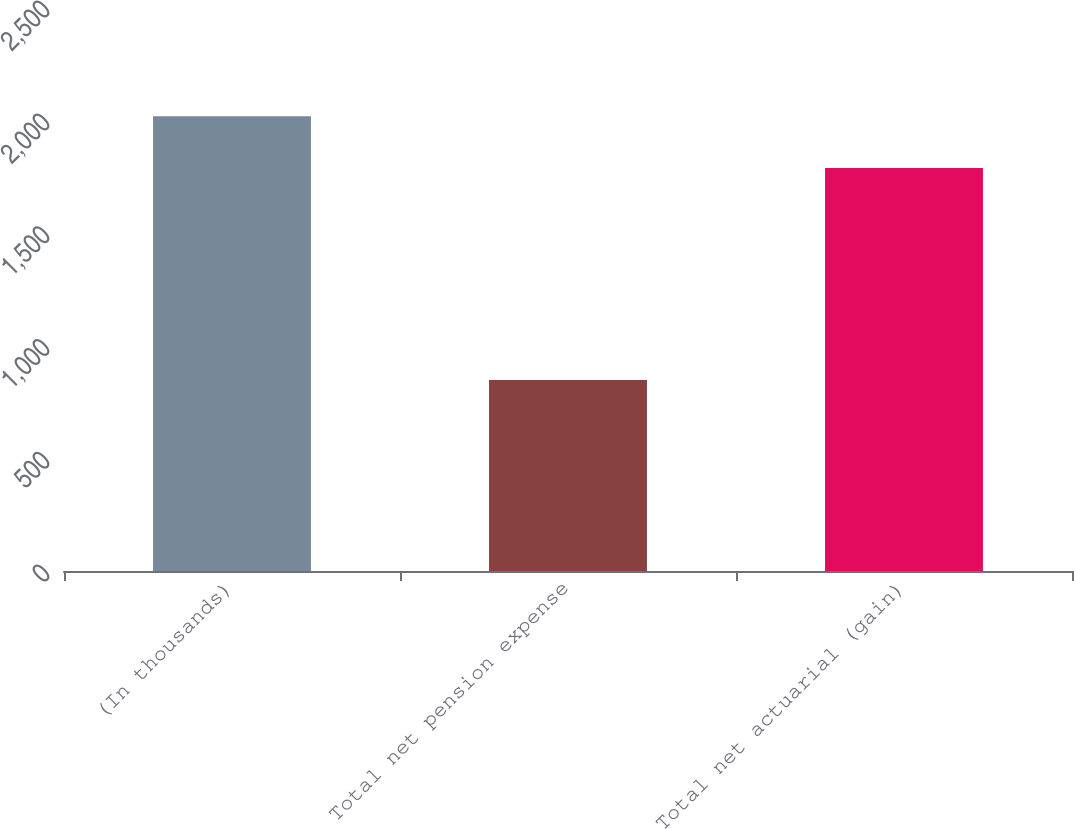Convert chart to OTSL. <chart><loc_0><loc_0><loc_500><loc_500><bar_chart><fcel>(In thousands)<fcel>Total net pension expense<fcel>Total net actuarial (gain)<nl><fcel>2016<fcel>847<fcel>1786<nl></chart> 